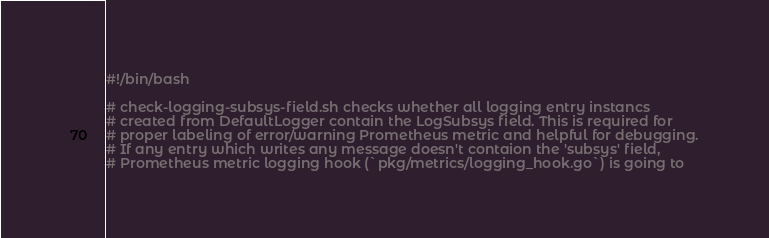Convert code to text. <code><loc_0><loc_0><loc_500><loc_500><_Bash_>#!/bin/bash

# check-logging-subsys-field.sh checks whether all logging entry instancs
# created from DefaultLogger contain the LogSubsys field. This is required for
# proper labeling of error/warning Prometheus metric and helpful for debugging.
# If any entry which writes any message doesn't contaion the 'subsys' field,
# Prometheus metric logging hook (`pkg/metrics/logging_hook.go`) is going to</code> 